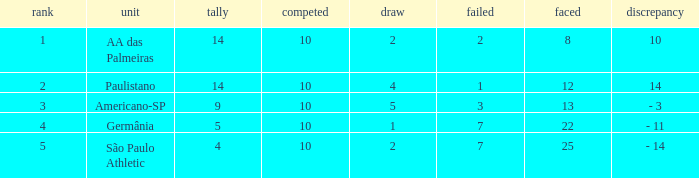What is the highest Drawn when the lost is 7 and the points are more than 4, and the against is less than 22? None. 